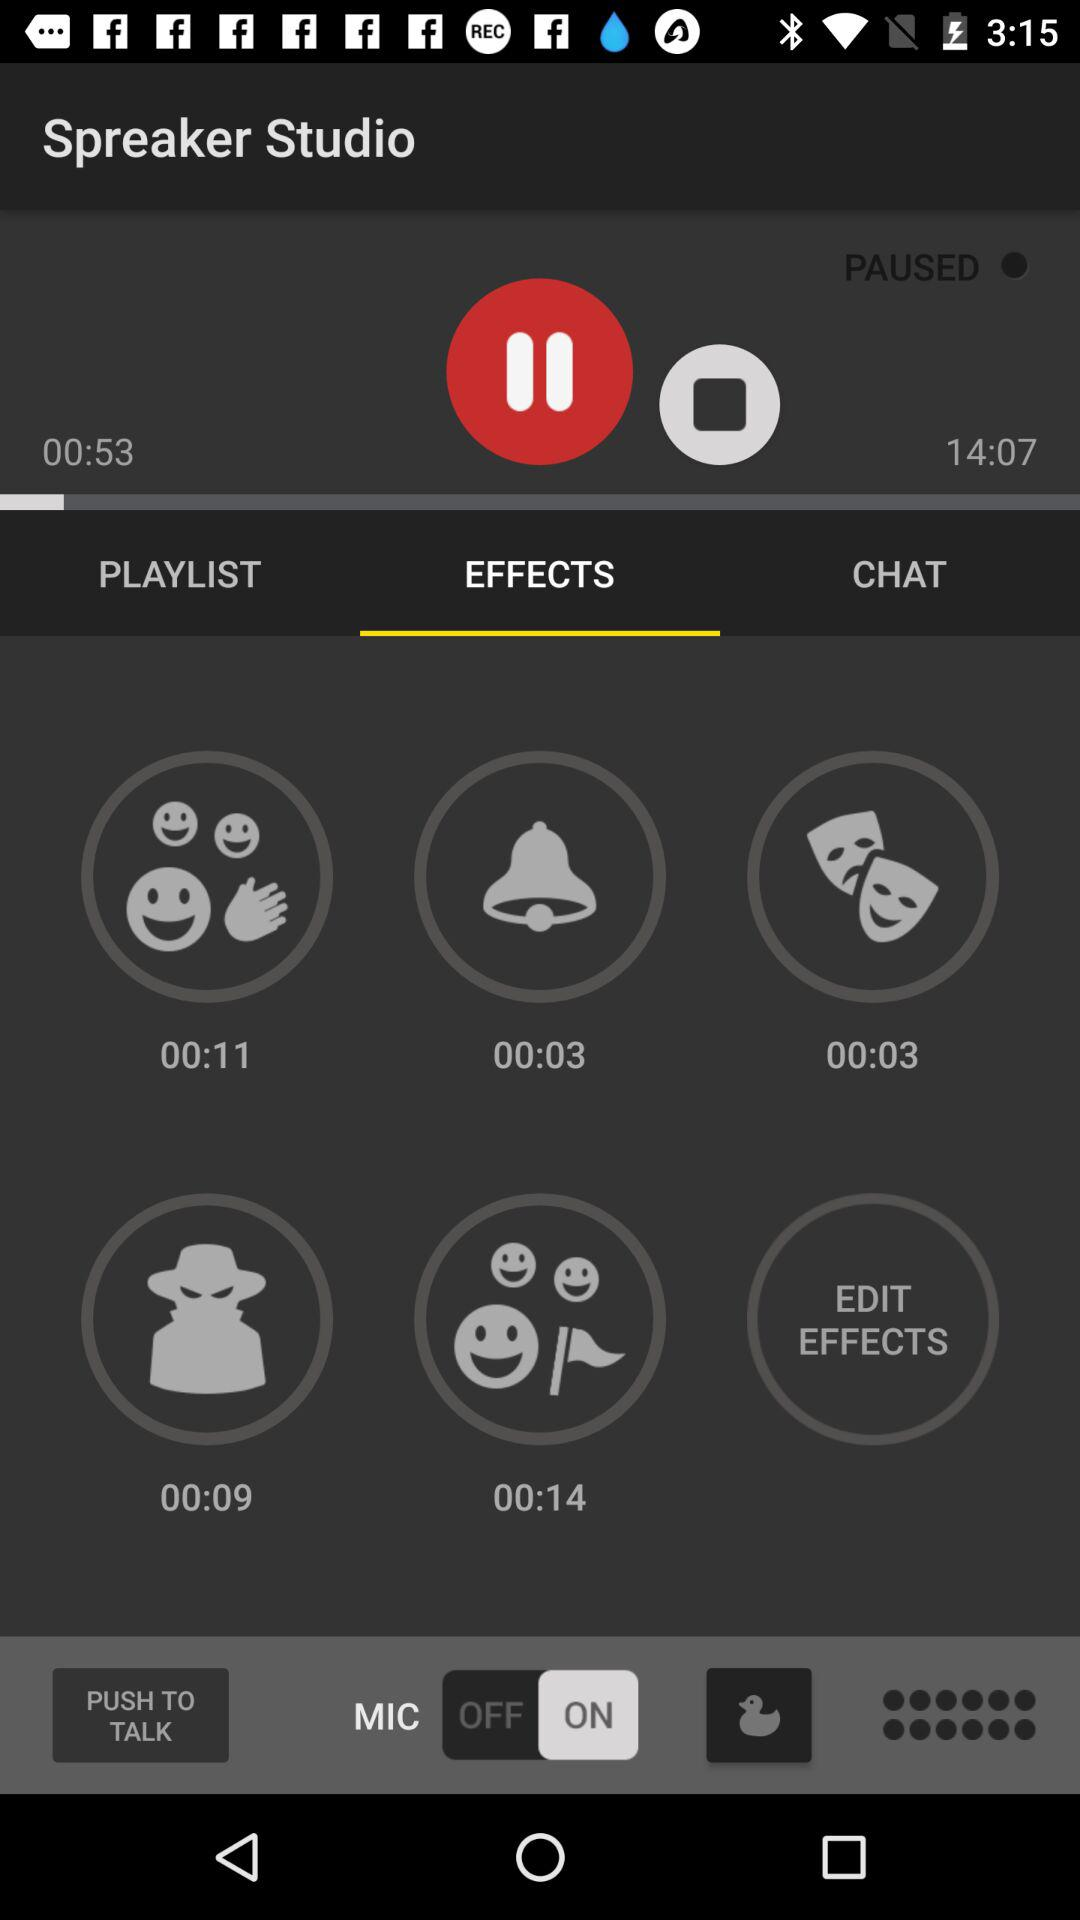How much audio has been played? The audio has been played till 53 seconds. 